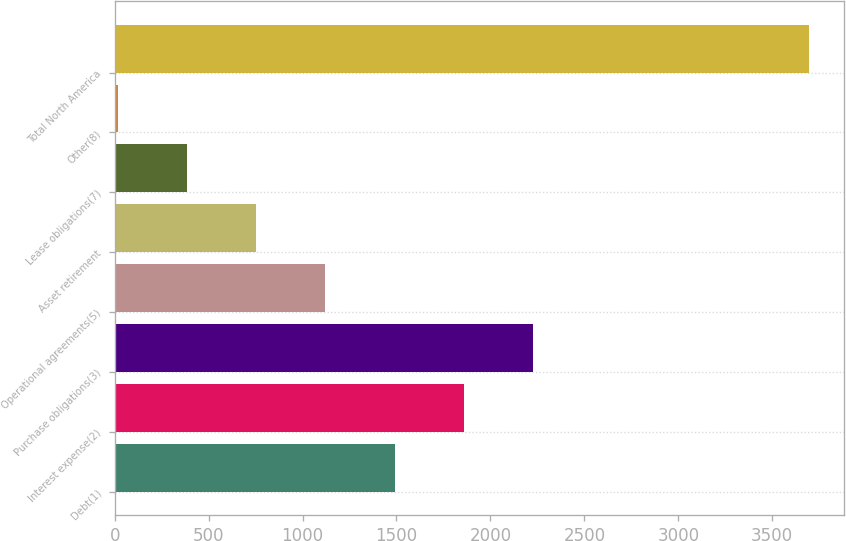Convert chart. <chart><loc_0><loc_0><loc_500><loc_500><bar_chart><fcel>Debt(1)<fcel>Interest expense(2)<fcel>Purchase obligations(3)<fcel>Operational agreements(5)<fcel>Asset retirement<fcel>Lease obligations(7)<fcel>Other(8)<fcel>Total North America<nl><fcel>1490<fcel>1858<fcel>2226<fcel>1122<fcel>754<fcel>386<fcel>18<fcel>3698<nl></chart> 